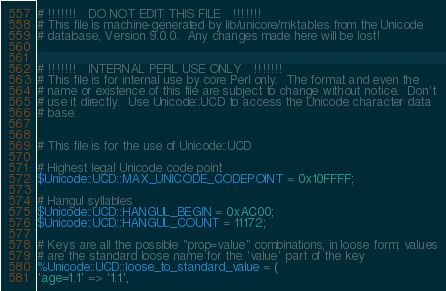Convert code to text. <code><loc_0><loc_0><loc_500><loc_500><_Perl_># !!!!!!!   DO NOT EDIT THIS FILE   !!!!!!!
# This file is machine-generated by lib/unicore/mktables from the Unicode
# database, Version 9.0.0.  Any changes made here will be lost!


# !!!!!!!   INTERNAL PERL USE ONLY   !!!!!!!
# This file is for internal use by core Perl only.  The format and even the
# name or existence of this file are subject to change without notice.  Don't
# use it directly.  Use Unicode::UCD to access the Unicode character data
# base.


# This file is for the use of Unicode::UCD

# Highest legal Unicode code point
$Unicode::UCD::MAX_UNICODE_CODEPOINT = 0x10FFFF;

# Hangul syllables
$Unicode::UCD::HANGUL_BEGIN = 0xAC00;
$Unicode::UCD::HANGUL_COUNT = 11172;

# Keys are all the possible "prop=value" combinations, in loose form; values
# are the standard loose name for the 'value' part of the key
%Unicode::UCD::loose_to_standard_value = (
'age=1.1' => '1.1',</code> 